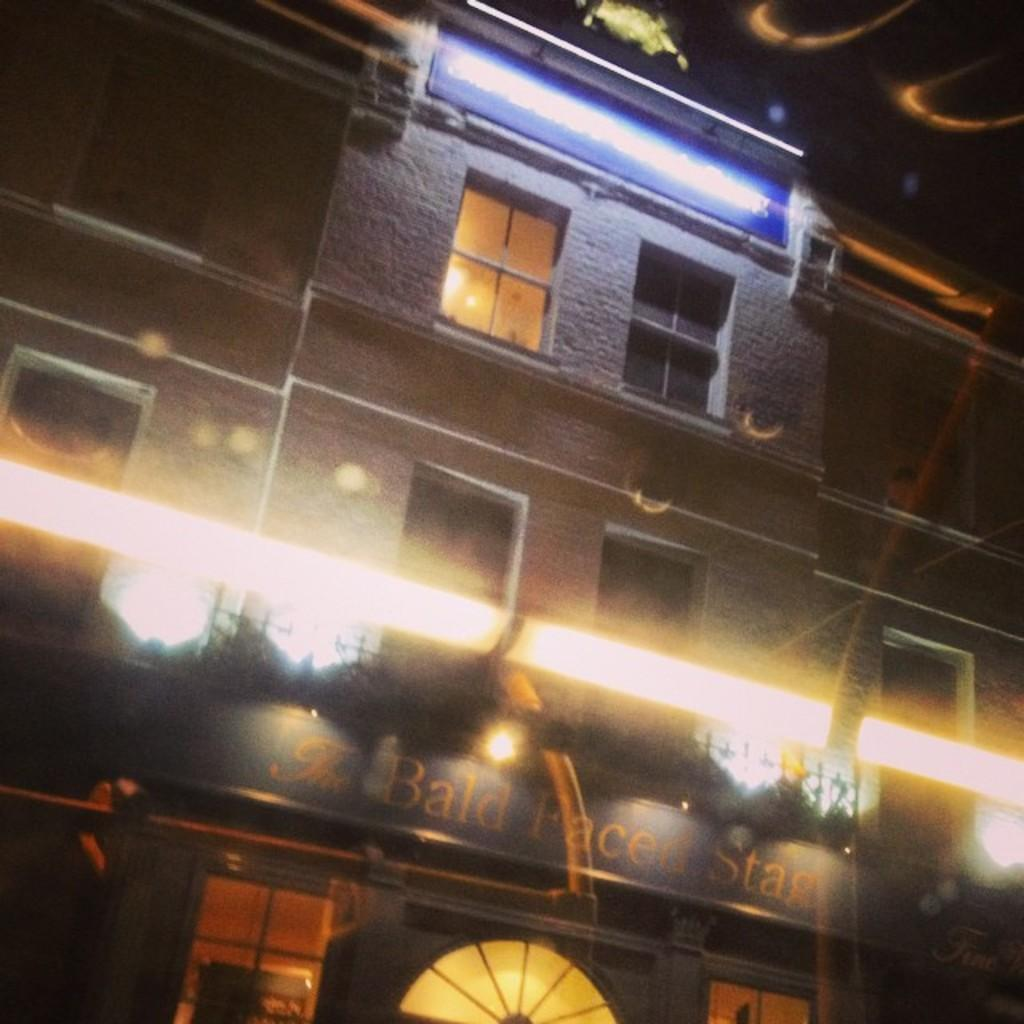What type of structure is present in the image? The image contains a building. What features can be observed on the building? The building has windows and doors. Is there any signage or identification on the building? Yes, there is a name board attached to the building wall. What can be seen in terms of illumination in the image? There are lights visible in the image. What type of operation is being performed on the ship in the image? There is no ship present in the image; it features a building with windows, doors, and a name board. 